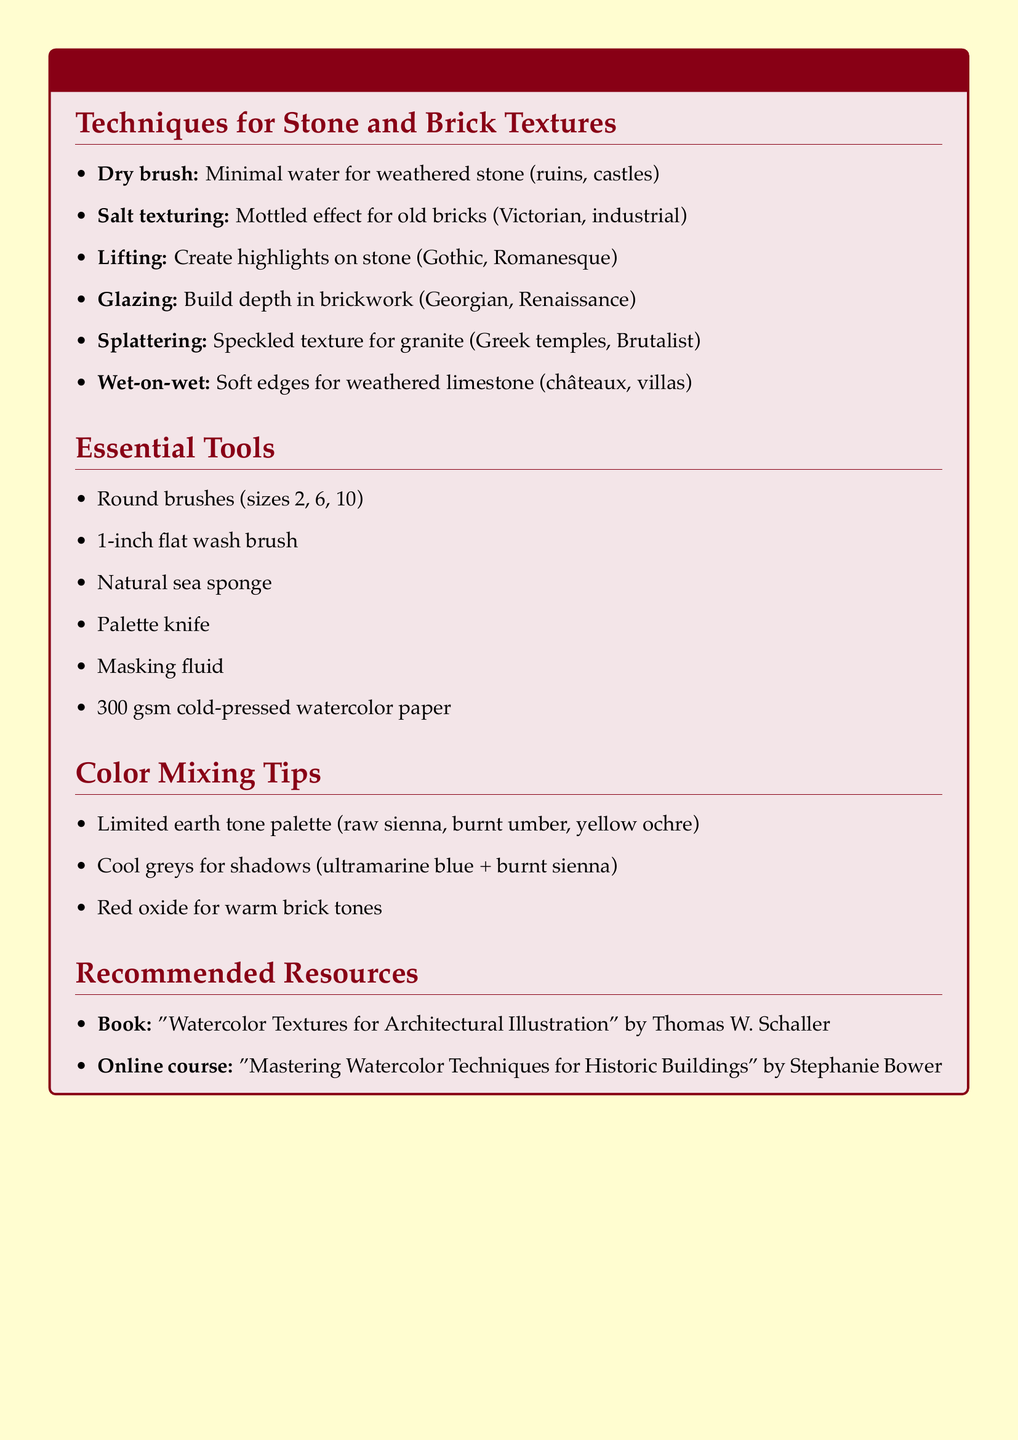What is the technique that uses minimal water to create rough surfaces? The document describes "Dry brush" as a technique to create rough, textured surfaces resembling weathered stone with minimal water.
Answer: Dry brush Which technique involves sprinkling salt on wet paint? The document explains that "Salt texturing" is the technique where salt is sprinkled on wet paint to create a mottled effect.
Answer: Salt texturing What is the purpose of lifting in watercolor painting? Lifting is used to remove paint with a damp brush or sponge to create highlights and worn areas on stone surfaces, as detailed in the document.
Answer: Create highlights What types of buildings are ideal for the dry brush technique? The document states that dry brush is ideal for depicting ancient ruins or medieval castles.
Answer: Ancient ruins or medieval castles Which essential tool is listed as flat wash brush? The document includes "1-inch flat wash brush" in the list of essential tools for watercolor painting.
Answer: 1-inch flat wash brush What is the limited palette suggested for realistic stone colors? The document recommends using earth tones such as raw sienna, burnt umber, and yellow ochre for realistic stone colors.
Answer: Raw sienna, burnt umber, yellow ochre Who is the author of the recommended book on watercolor textures? The author's name mentioned in the document for the book "Watercolor Textures for Architectural Illustration" is Thomas W. Schaller.
Answer: Thomas W. Schaller What type of resource is "Mastering Watercolor Techniques for Historic Buildings"? The document categorizes "Mastering Watercolor Techniques for Historic Buildings" as an online course.
Answer: Online course 